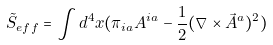<formula> <loc_0><loc_0><loc_500><loc_500>\tilde { S } _ { e f f } = \int d ^ { 4 } x ( \pi _ { i a } A ^ { i a } - \frac { 1 } { 2 } ( \nabla \times \vec { A } ^ { a } ) ^ { 2 } )</formula> 